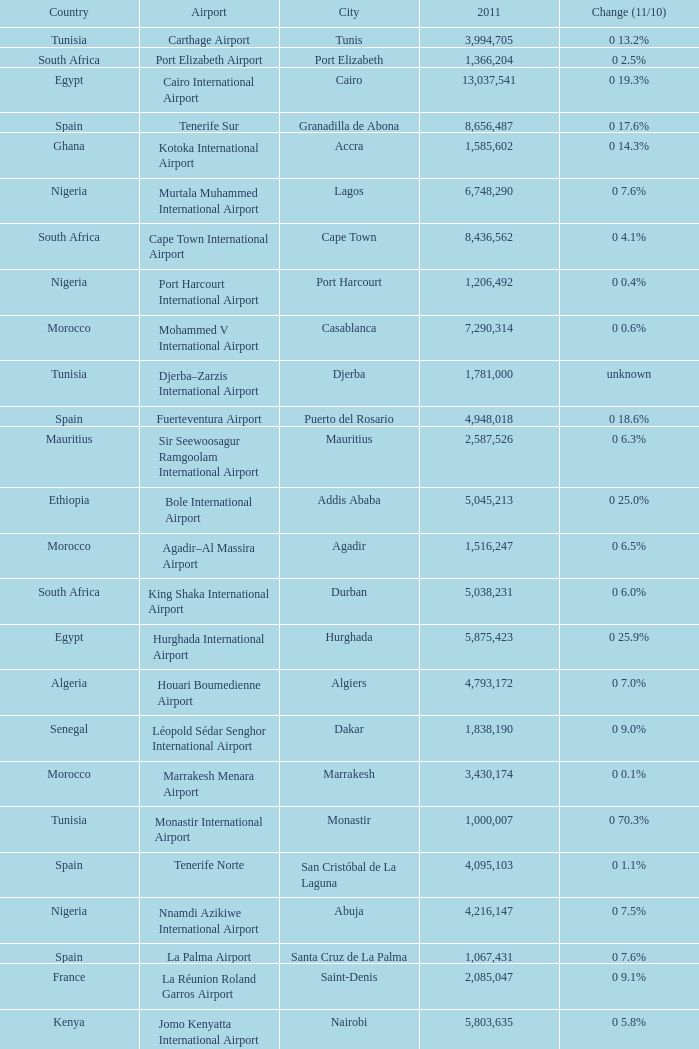Which 2011 has an Airport of bole international airport? 5045213.0. 